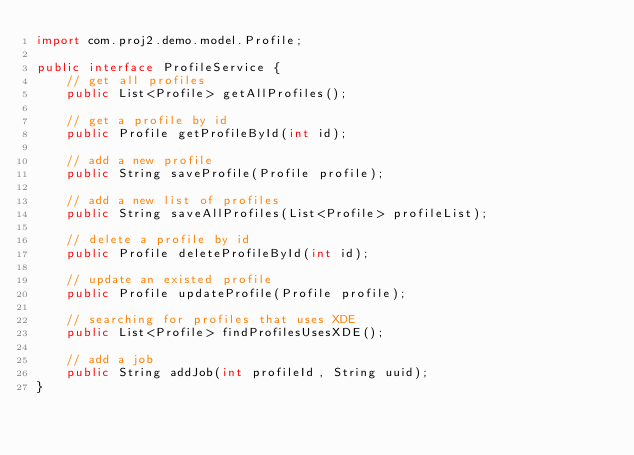Convert code to text. <code><loc_0><loc_0><loc_500><loc_500><_Java_>import com.proj2.demo.model.Profile;

public interface ProfileService {
	// get all profiles
	public List<Profile> getAllProfiles();
	
	// get a profile by id
	public Profile getProfileById(int id);
	
	// add a new profile
	public String saveProfile(Profile profile);
	
	// add a new list of profiles
	public String saveAllProfiles(List<Profile> profileList);
	
	// delete a profile by id
	public Profile deleteProfileById(int id);
	
	// update an existed profile
	public Profile updateProfile(Profile profile);
	
	// searching for profiles that uses XDE
	public List<Profile> findProfilesUsesXDE();
	
	// add a job
	public String addJob(int profileId, String uuid);
}</code> 